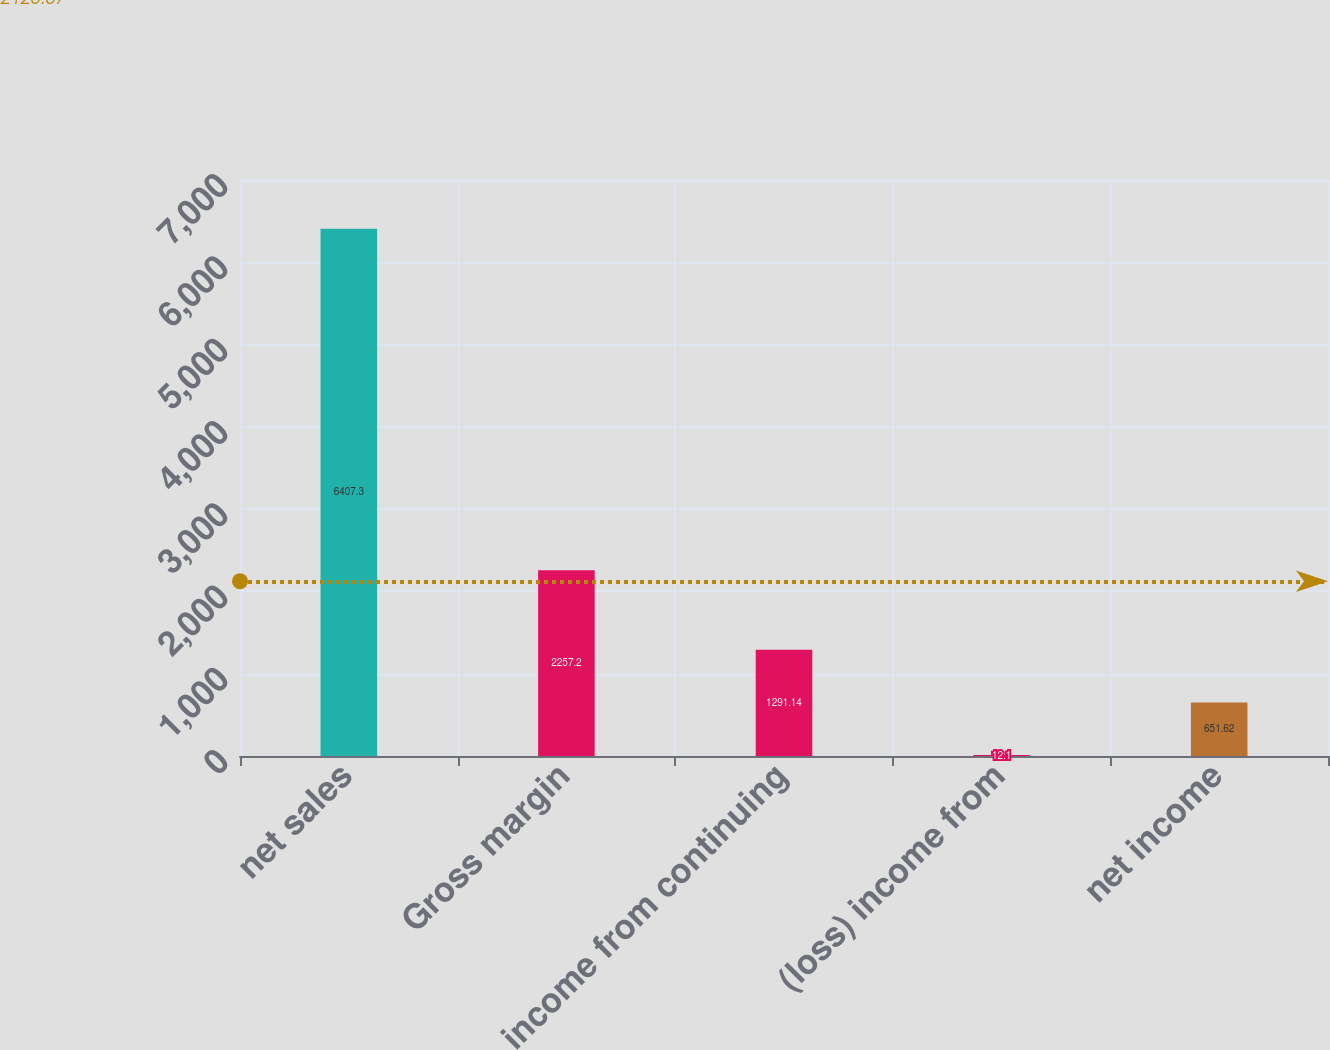<chart> <loc_0><loc_0><loc_500><loc_500><bar_chart><fcel>net sales<fcel>Gross margin<fcel>income from continuing<fcel>(loss) income from<fcel>net income<nl><fcel>6407.3<fcel>2257.2<fcel>1291.14<fcel>12.1<fcel>651.62<nl></chart> 